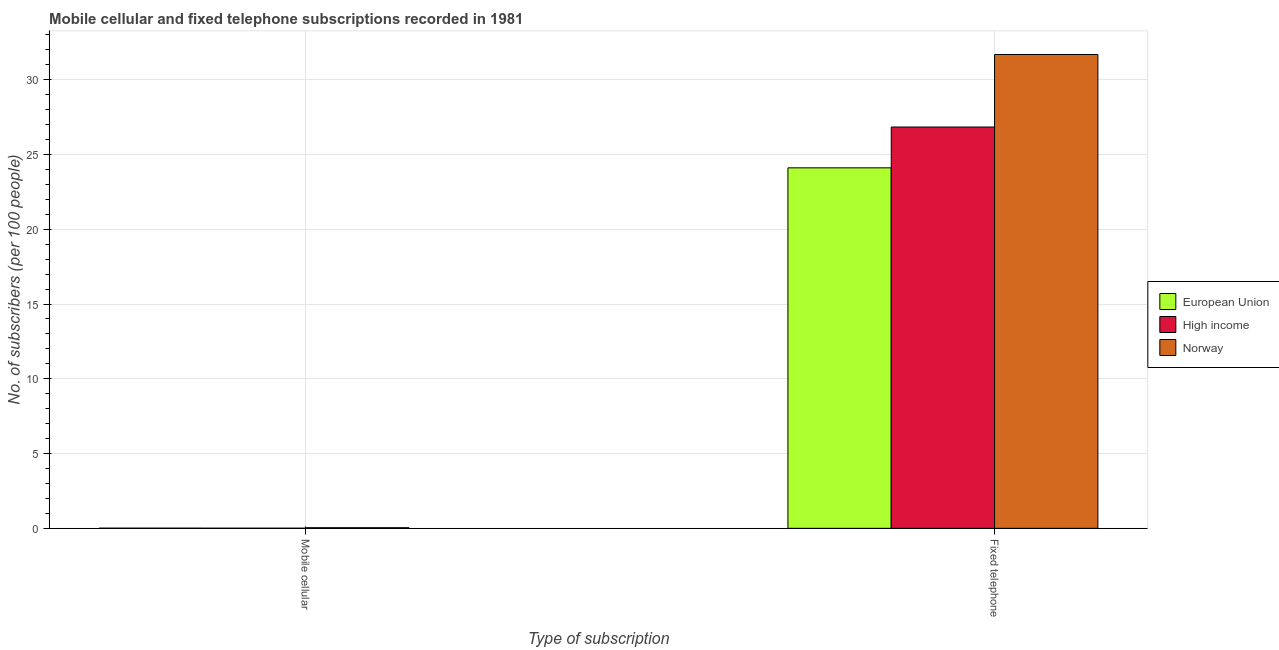How many groups of bars are there?
Your answer should be very brief. 2. Are the number of bars per tick equal to the number of legend labels?
Provide a succinct answer. Yes. How many bars are there on the 1st tick from the right?
Your response must be concise. 3. What is the label of the 1st group of bars from the left?
Give a very brief answer. Mobile cellular. What is the number of fixed telephone subscribers in European Union?
Make the answer very short. 24.11. Across all countries, what is the maximum number of fixed telephone subscribers?
Your answer should be compact. 31.69. Across all countries, what is the minimum number of mobile cellular subscribers?
Provide a succinct answer. 0.01. In which country was the number of fixed telephone subscribers maximum?
Provide a short and direct response. Norway. In which country was the number of fixed telephone subscribers minimum?
Your response must be concise. European Union. What is the total number of mobile cellular subscribers in the graph?
Provide a succinct answer. 0.06. What is the difference between the number of mobile cellular subscribers in High income and that in Norway?
Keep it short and to the point. -0.03. What is the difference between the number of mobile cellular subscribers in High income and the number of fixed telephone subscribers in Norway?
Ensure brevity in your answer.  -31.68. What is the average number of mobile cellular subscribers per country?
Your answer should be very brief. 0.02. What is the difference between the number of mobile cellular subscribers and number of fixed telephone subscribers in High income?
Keep it short and to the point. -26.83. In how many countries, is the number of fixed telephone subscribers greater than 9 ?
Ensure brevity in your answer.  3. What is the ratio of the number of fixed telephone subscribers in Norway to that in High income?
Ensure brevity in your answer.  1.18. In how many countries, is the number of mobile cellular subscribers greater than the average number of mobile cellular subscribers taken over all countries?
Give a very brief answer. 1. Are all the bars in the graph horizontal?
Give a very brief answer. No. How many countries are there in the graph?
Offer a very short reply. 3. Are the values on the major ticks of Y-axis written in scientific E-notation?
Provide a succinct answer. No. Does the graph contain any zero values?
Keep it short and to the point. No. Where does the legend appear in the graph?
Offer a terse response. Center right. How are the legend labels stacked?
Keep it short and to the point. Vertical. What is the title of the graph?
Offer a terse response. Mobile cellular and fixed telephone subscriptions recorded in 1981. Does "Europe(all income levels)" appear as one of the legend labels in the graph?
Make the answer very short. No. What is the label or title of the X-axis?
Your answer should be very brief. Type of subscription. What is the label or title of the Y-axis?
Provide a succinct answer. No. of subscribers (per 100 people). What is the No. of subscribers (per 100 people) of European Union in Mobile cellular?
Offer a very short reply. 0.01. What is the No. of subscribers (per 100 people) of High income in Mobile cellular?
Make the answer very short. 0.01. What is the No. of subscribers (per 100 people) in Norway in Mobile cellular?
Keep it short and to the point. 0.04. What is the No. of subscribers (per 100 people) of European Union in Fixed telephone?
Provide a succinct answer. 24.11. What is the No. of subscribers (per 100 people) of High income in Fixed telephone?
Ensure brevity in your answer.  26.84. What is the No. of subscribers (per 100 people) of Norway in Fixed telephone?
Keep it short and to the point. 31.69. Across all Type of subscription, what is the maximum No. of subscribers (per 100 people) in European Union?
Give a very brief answer. 24.11. Across all Type of subscription, what is the maximum No. of subscribers (per 100 people) in High income?
Provide a short and direct response. 26.84. Across all Type of subscription, what is the maximum No. of subscribers (per 100 people) of Norway?
Ensure brevity in your answer.  31.69. Across all Type of subscription, what is the minimum No. of subscribers (per 100 people) in European Union?
Your answer should be very brief. 0.01. Across all Type of subscription, what is the minimum No. of subscribers (per 100 people) of High income?
Offer a very short reply. 0.01. Across all Type of subscription, what is the minimum No. of subscribers (per 100 people) in Norway?
Offer a terse response. 0.04. What is the total No. of subscribers (per 100 people) of European Union in the graph?
Keep it short and to the point. 24.12. What is the total No. of subscribers (per 100 people) of High income in the graph?
Offer a very short reply. 26.85. What is the total No. of subscribers (per 100 people) of Norway in the graph?
Provide a short and direct response. 31.73. What is the difference between the No. of subscribers (per 100 people) of European Union in Mobile cellular and that in Fixed telephone?
Your answer should be compact. -24.1. What is the difference between the No. of subscribers (per 100 people) of High income in Mobile cellular and that in Fixed telephone?
Provide a succinct answer. -26.83. What is the difference between the No. of subscribers (per 100 people) in Norway in Mobile cellular and that in Fixed telephone?
Your response must be concise. -31.65. What is the difference between the No. of subscribers (per 100 people) in European Union in Mobile cellular and the No. of subscribers (per 100 people) in High income in Fixed telephone?
Offer a very short reply. -26.83. What is the difference between the No. of subscribers (per 100 people) in European Union in Mobile cellular and the No. of subscribers (per 100 people) in Norway in Fixed telephone?
Make the answer very short. -31.68. What is the difference between the No. of subscribers (per 100 people) in High income in Mobile cellular and the No. of subscribers (per 100 people) in Norway in Fixed telephone?
Your answer should be very brief. -31.68. What is the average No. of subscribers (per 100 people) in European Union per Type of subscription?
Ensure brevity in your answer.  12.06. What is the average No. of subscribers (per 100 people) of High income per Type of subscription?
Give a very brief answer. 13.42. What is the average No. of subscribers (per 100 people) in Norway per Type of subscription?
Ensure brevity in your answer.  15.86. What is the difference between the No. of subscribers (per 100 people) of European Union and No. of subscribers (per 100 people) of High income in Mobile cellular?
Provide a succinct answer. 0. What is the difference between the No. of subscribers (per 100 people) of European Union and No. of subscribers (per 100 people) of Norway in Mobile cellular?
Provide a short and direct response. -0.03. What is the difference between the No. of subscribers (per 100 people) of High income and No. of subscribers (per 100 people) of Norway in Mobile cellular?
Provide a short and direct response. -0.03. What is the difference between the No. of subscribers (per 100 people) of European Union and No. of subscribers (per 100 people) of High income in Fixed telephone?
Provide a short and direct response. -2.73. What is the difference between the No. of subscribers (per 100 people) of European Union and No. of subscribers (per 100 people) of Norway in Fixed telephone?
Ensure brevity in your answer.  -7.58. What is the difference between the No. of subscribers (per 100 people) of High income and No. of subscribers (per 100 people) of Norway in Fixed telephone?
Provide a short and direct response. -4.85. What is the ratio of the No. of subscribers (per 100 people) of European Union in Mobile cellular to that in Fixed telephone?
Offer a terse response. 0. What is the ratio of the No. of subscribers (per 100 people) of High income in Mobile cellular to that in Fixed telephone?
Provide a short and direct response. 0. What is the ratio of the No. of subscribers (per 100 people) in Norway in Mobile cellular to that in Fixed telephone?
Make the answer very short. 0. What is the difference between the highest and the second highest No. of subscribers (per 100 people) of European Union?
Offer a very short reply. 24.1. What is the difference between the highest and the second highest No. of subscribers (per 100 people) of High income?
Your response must be concise. 26.83. What is the difference between the highest and the second highest No. of subscribers (per 100 people) of Norway?
Your answer should be compact. 31.65. What is the difference between the highest and the lowest No. of subscribers (per 100 people) in European Union?
Provide a short and direct response. 24.1. What is the difference between the highest and the lowest No. of subscribers (per 100 people) in High income?
Provide a short and direct response. 26.83. What is the difference between the highest and the lowest No. of subscribers (per 100 people) in Norway?
Ensure brevity in your answer.  31.65. 